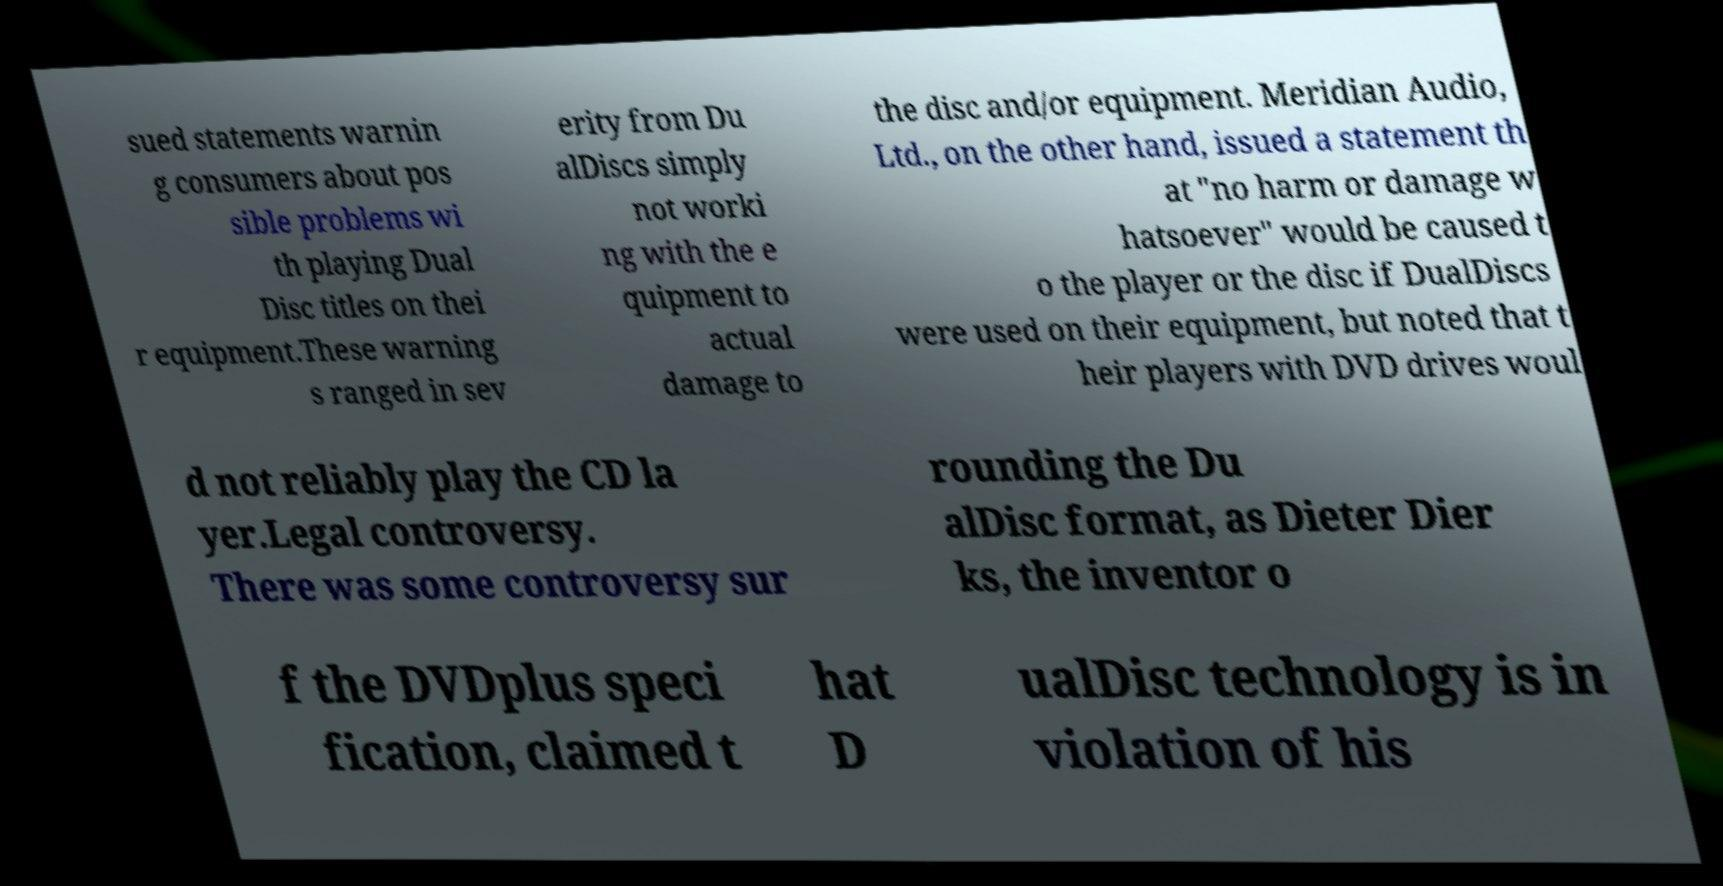Could you extract and type out the text from this image? sued statements warnin g consumers about pos sible problems wi th playing Dual Disc titles on thei r equipment.These warning s ranged in sev erity from Du alDiscs simply not worki ng with the e quipment to actual damage to the disc and/or equipment. Meridian Audio, Ltd., on the other hand, issued a statement th at "no harm or damage w hatsoever" would be caused t o the player or the disc if DualDiscs were used on their equipment, but noted that t heir players with DVD drives woul d not reliably play the CD la yer.Legal controversy. There was some controversy sur rounding the Du alDisc format, as Dieter Dier ks, the inventor o f the DVDplus speci fication, claimed t hat D ualDisc technology is in violation of his 